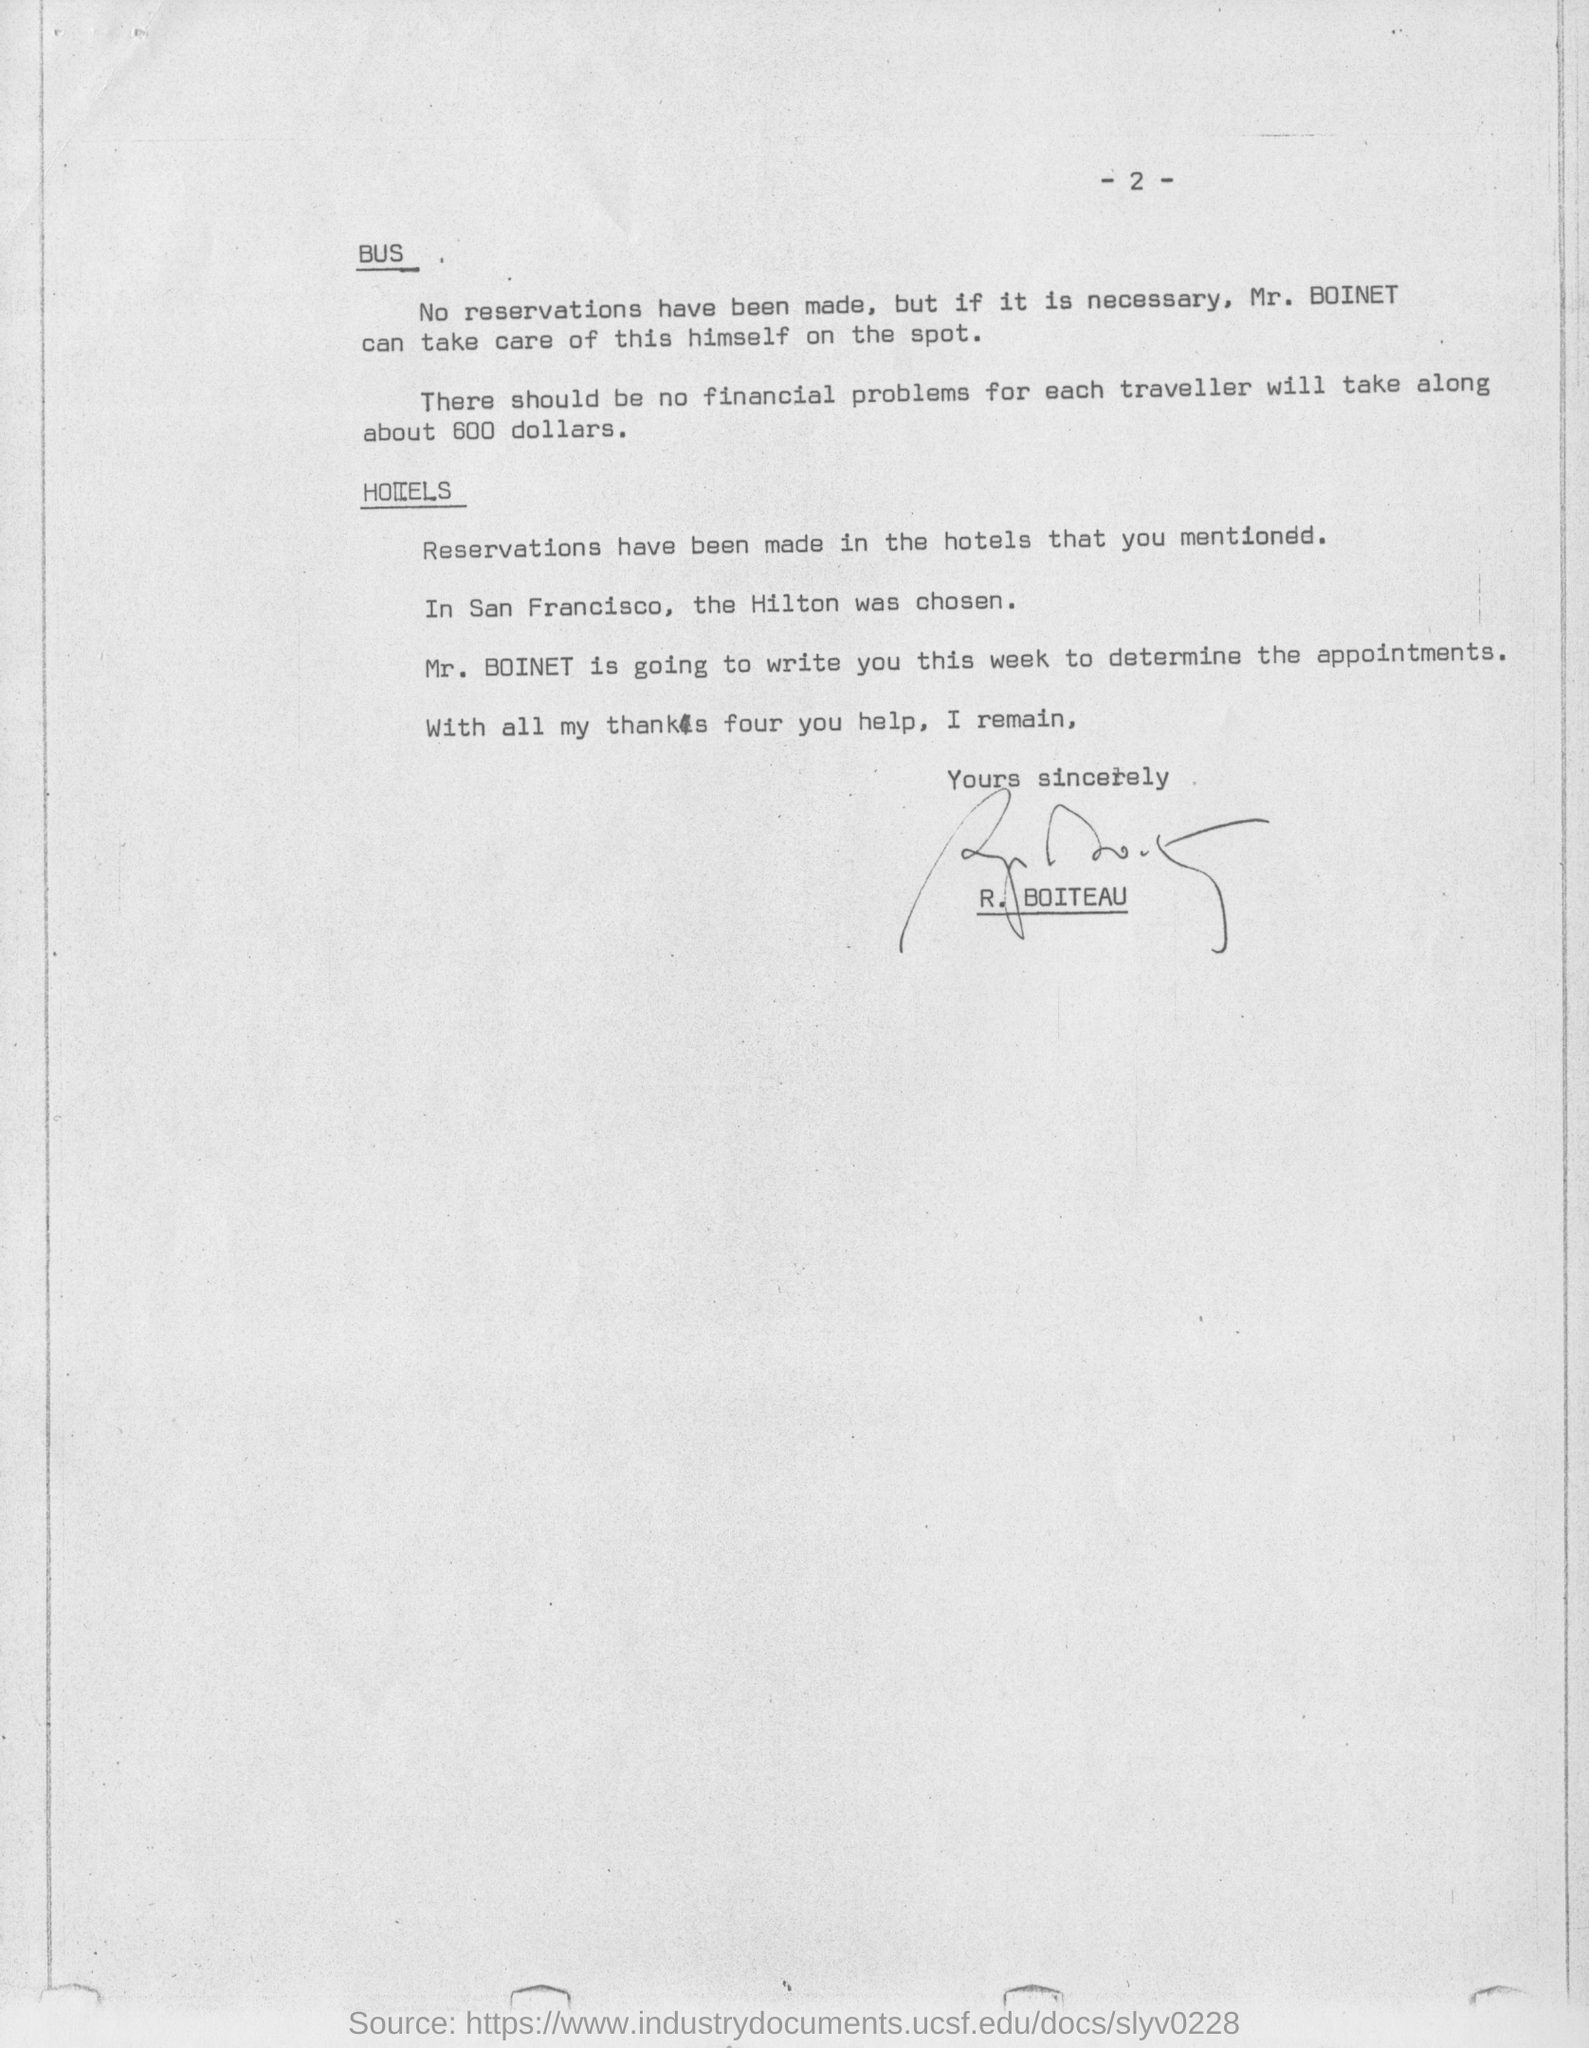How much should each traveller take along?
Provide a short and direct response. About 600 dollars. For whom the reservation is not made?
Your answer should be very brief. Mr. Boinet. Who has signed the document?
Provide a succinct answer. R. BOITEAU. 